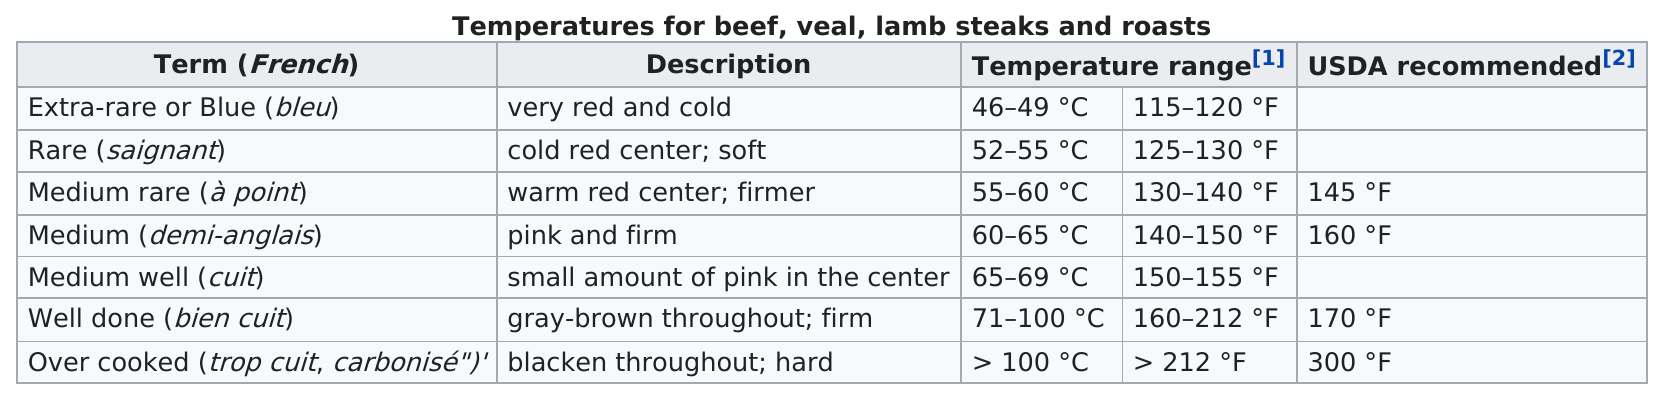List a handful of essential elements in this visual. The term 'over cooked' is the last one on the table. The average recommended temperature according to the USDA is 193.75 degrees Fahrenheit. The last term listed in the table is "Over cooked" (trop cuit, carbonisé), which refers to a situation where the food is cooked for too long, resulting in it being burnt or charred. The top term is "red" and it is very cold. Out of the consecutive terms starting from 2, how many do not meet the USDA recommended temperature? 